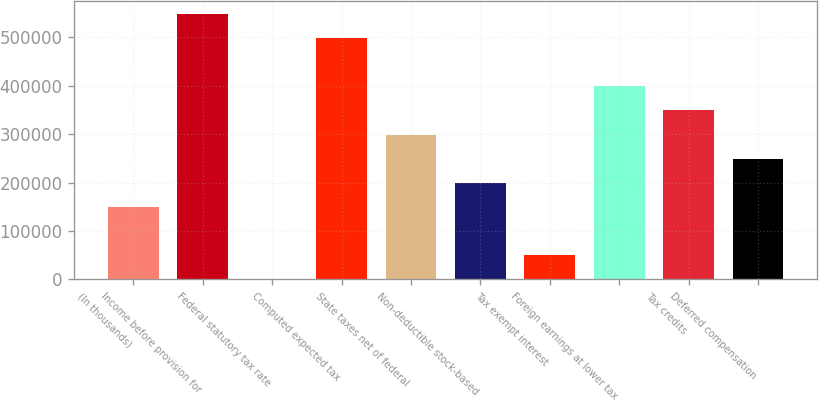Convert chart to OTSL. <chart><loc_0><loc_0><loc_500><loc_500><bar_chart><fcel>(In thousands)<fcel>Income before provision for<fcel>Federal statutory tax rate<fcel>Computed expected tax<fcel>State taxes net of federal<fcel>Non-deductible stock-based<fcel>Tax exempt interest<fcel>Foreign earnings at lower tax<fcel>Tax credits<fcel>Deferred compensation<nl><fcel>149480<fcel>547999<fcel>35<fcel>498184<fcel>298924<fcel>199295<fcel>49849.9<fcel>398554<fcel>348739<fcel>249110<nl></chart> 